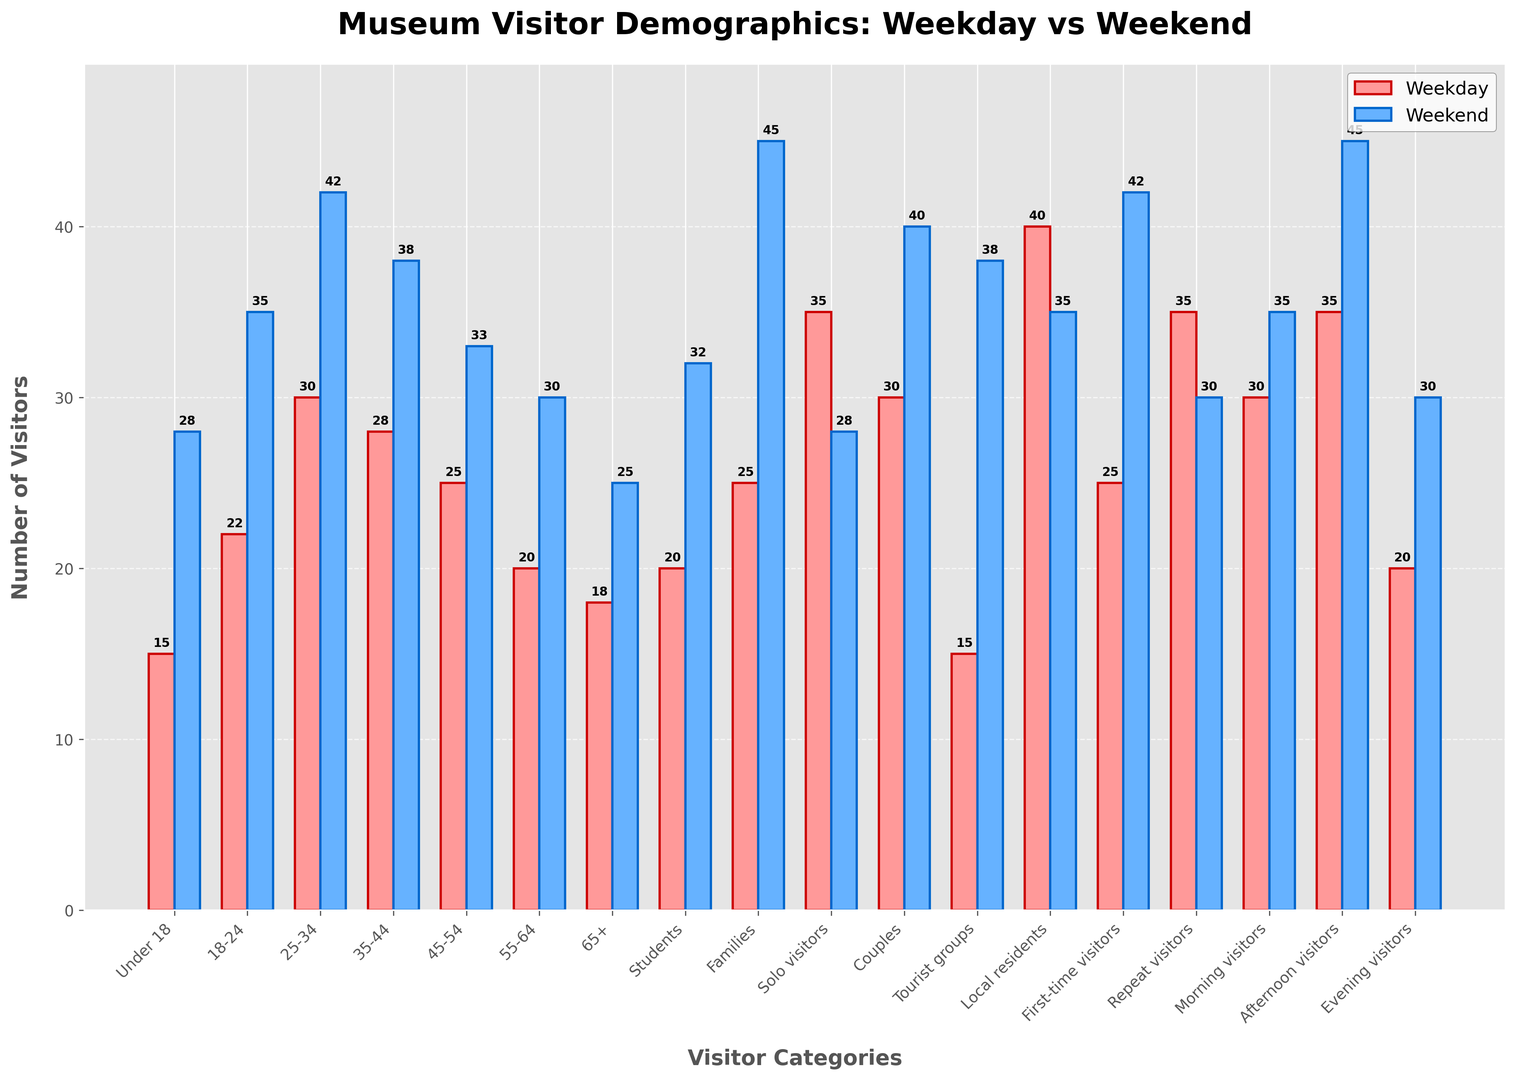Which age group has the highest number of visitors on the weekend? Look for the tallest weekend bar (blue) and identify its corresponding age group. The tallest bar represents the "Families" category.
Answer: Families What is the total number of visitors for the '18-24' age group across both weekdays and weekends? Add the weekday and weekend values for '18-24': 22 (weekday) + 35 (weekend) = 57.
Answer: 57 How does the number of solo visitors on weekdays compare to their numbers on weekends? Compare the height of the red bar (weekday) and blue bar (weekend) for "Solo visitors". Weekday is 35 and Weekend is 28.
Answer: Weekday has more solo visitors Which group has a bigger increase in visitor count from weekday to weekend: 'Under 18' or 'Tourist groups'? Calculate the increase for each group: 
Under 18: 28 - 15 = 13 
Tourist groups: 38 - 15 = 23. Compare the differences.
Answer: Tourist groups What is the average number of visitors for the 'Local residents' category across weekdays and weekends? Add the weekday and weekend values for 'Local residents' and divide by 2: (40 + 35) / 2 = 37.5.
Answer: 37.5 Which visitor category has approximately the same number of visitors on both weekdays and weekends? Look for categories where the red (weekday) and blue (weekend) bars are nearly equal in height. The "Local residents" category has close counts (40 weekday, 35 weekend).
Answer: Local residents How many more families visit the museum on weekends compared to weekdays? Subtract the weekday value from the weekend value for "Families": 45 (weekend) - 25 (weekday) = 20.
Answer: 20 What is the combined total of visitors for 'Morning visitors' and 'Evening visitors' during the weekend? Sum the weekend values for 'Morning visitors' and 'Evening visitors': 35 (Morning) + 30 (Evening) = 65.
Answer: 65 Are there any categories where the number of visitors is higher on weekdays than on weekends? If so, name at least one. Compare the red (weekday) and blue (weekend) bars. The "Solo visitors" category has more visitors on weekdays (35) than weekends (28).
Answer: Solo visitors 